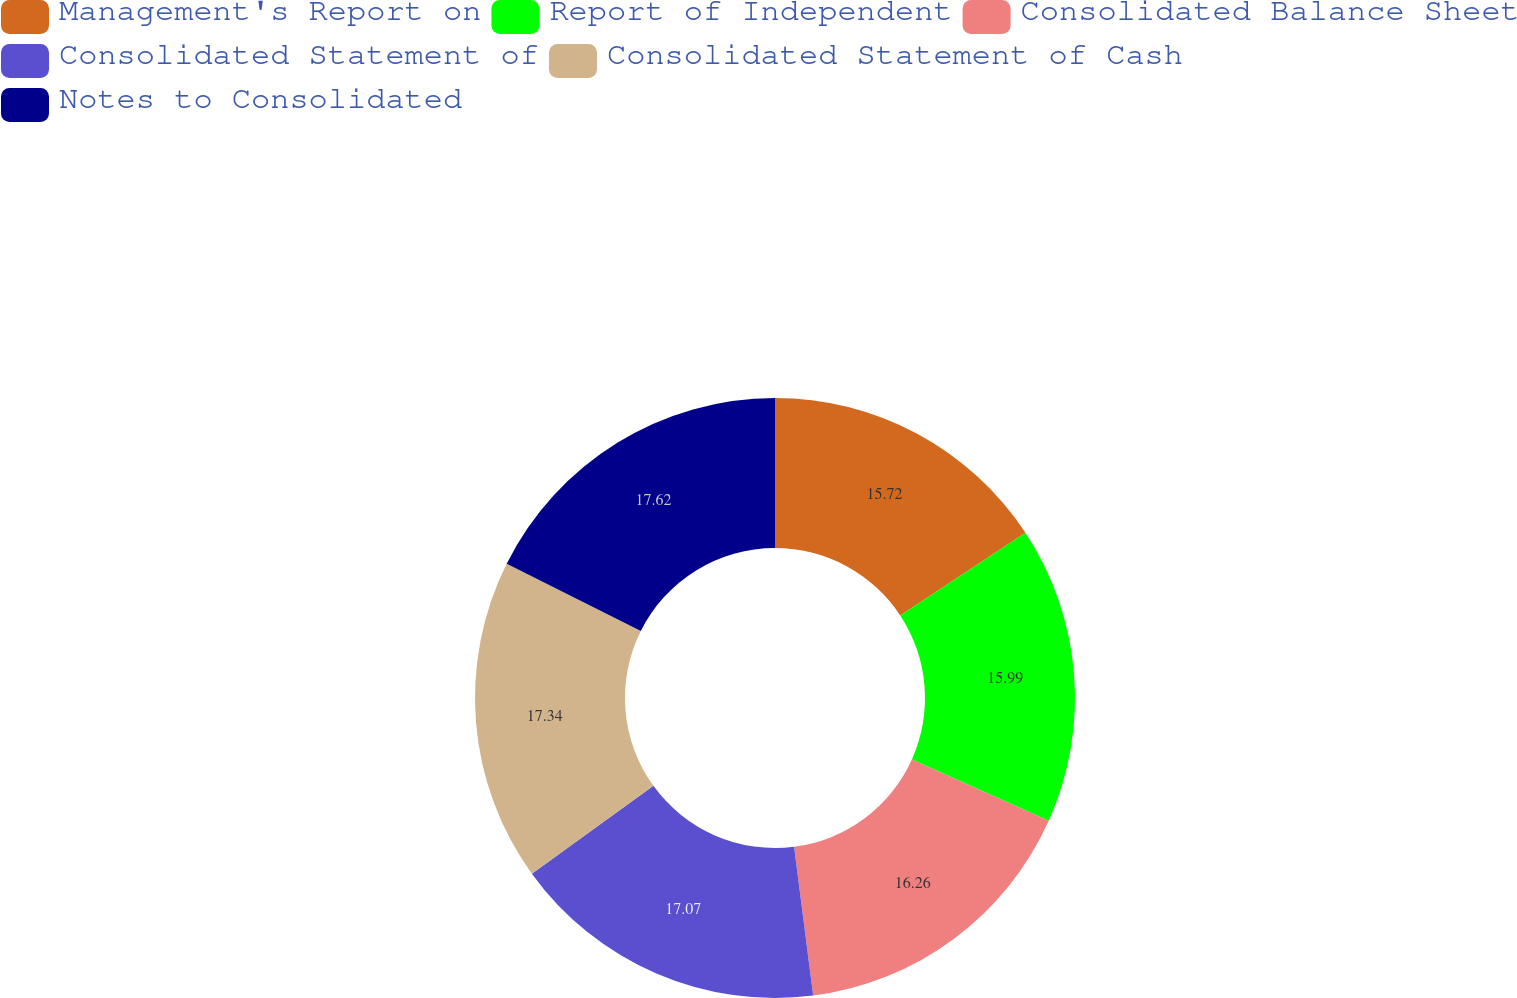<chart> <loc_0><loc_0><loc_500><loc_500><pie_chart><fcel>Management's Report on<fcel>Report of Independent<fcel>Consolidated Balance Sheet<fcel>Consolidated Statement of<fcel>Consolidated Statement of Cash<fcel>Notes to Consolidated<nl><fcel>15.72%<fcel>15.99%<fcel>16.26%<fcel>17.07%<fcel>17.34%<fcel>17.62%<nl></chart> 